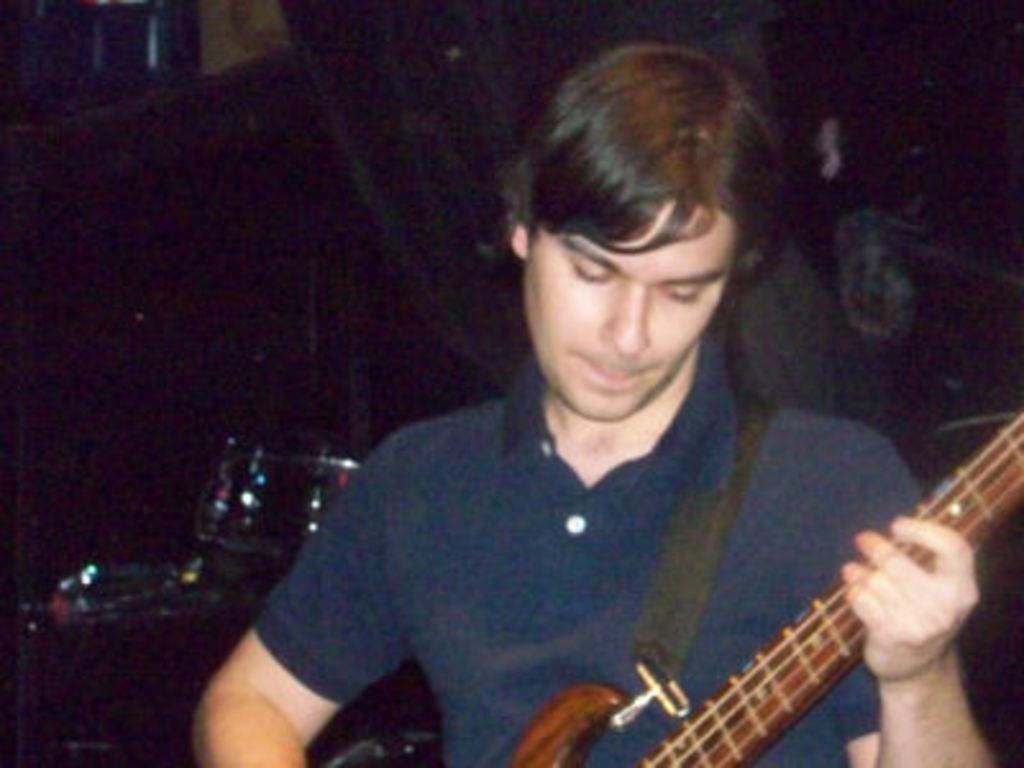Can you describe this image briefly? In this picture there is a man holding a guitar and looking at 